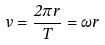<formula> <loc_0><loc_0><loc_500><loc_500>v = \frac { 2 \pi r } { T } = \omega r</formula> 